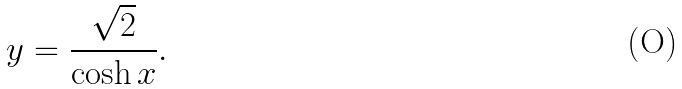Convert formula to latex. <formula><loc_0><loc_0><loc_500><loc_500>y = \frac { \sqrt { 2 } } { \cosh x } .</formula> 